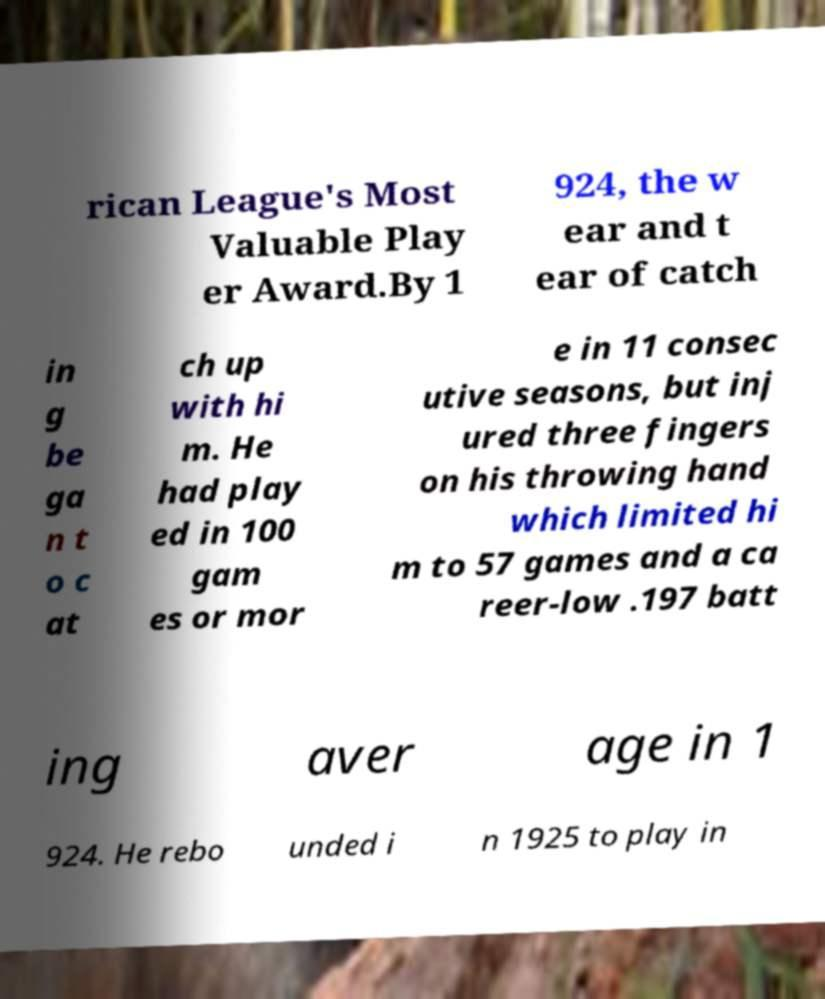I need the written content from this picture converted into text. Can you do that? rican League's Most Valuable Play er Award.By 1 924, the w ear and t ear of catch in g be ga n t o c at ch up with hi m. He had play ed in 100 gam es or mor e in 11 consec utive seasons, but inj ured three fingers on his throwing hand which limited hi m to 57 games and a ca reer-low .197 batt ing aver age in 1 924. He rebo unded i n 1925 to play in 